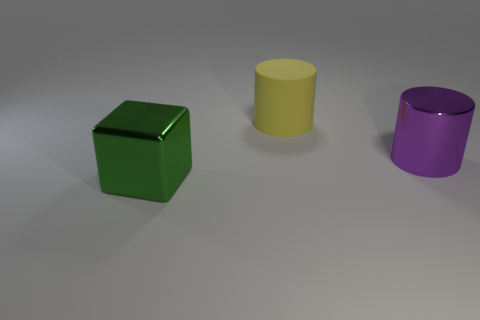Are there any other things that have the same color as the big cube?
Provide a short and direct response. No. There is a object that is in front of the yellow matte cylinder and left of the purple cylinder; how big is it?
Ensure brevity in your answer.  Large. How many other objects are the same material as the yellow thing?
Ensure brevity in your answer.  0. What is the shape of the big object that is on the left side of the purple metallic object and in front of the yellow thing?
Ensure brevity in your answer.  Cube. There is another large thing that is the same shape as the big yellow thing; what is it made of?
Offer a very short reply. Metal. Is the rubber thing the same shape as the large green thing?
Your response must be concise. No. How many cylinders are behind the large shiny object that is right of the large yellow matte cylinder?
Your answer should be compact. 1. There is a big object that is the same material as the cube; what is its shape?
Provide a short and direct response. Cylinder. How many yellow objects are large metal balls or big matte cylinders?
Ensure brevity in your answer.  1. Is there a big metallic object that is behind the large shiny thing left of the big metallic object to the right of the yellow matte thing?
Your answer should be compact. Yes. 